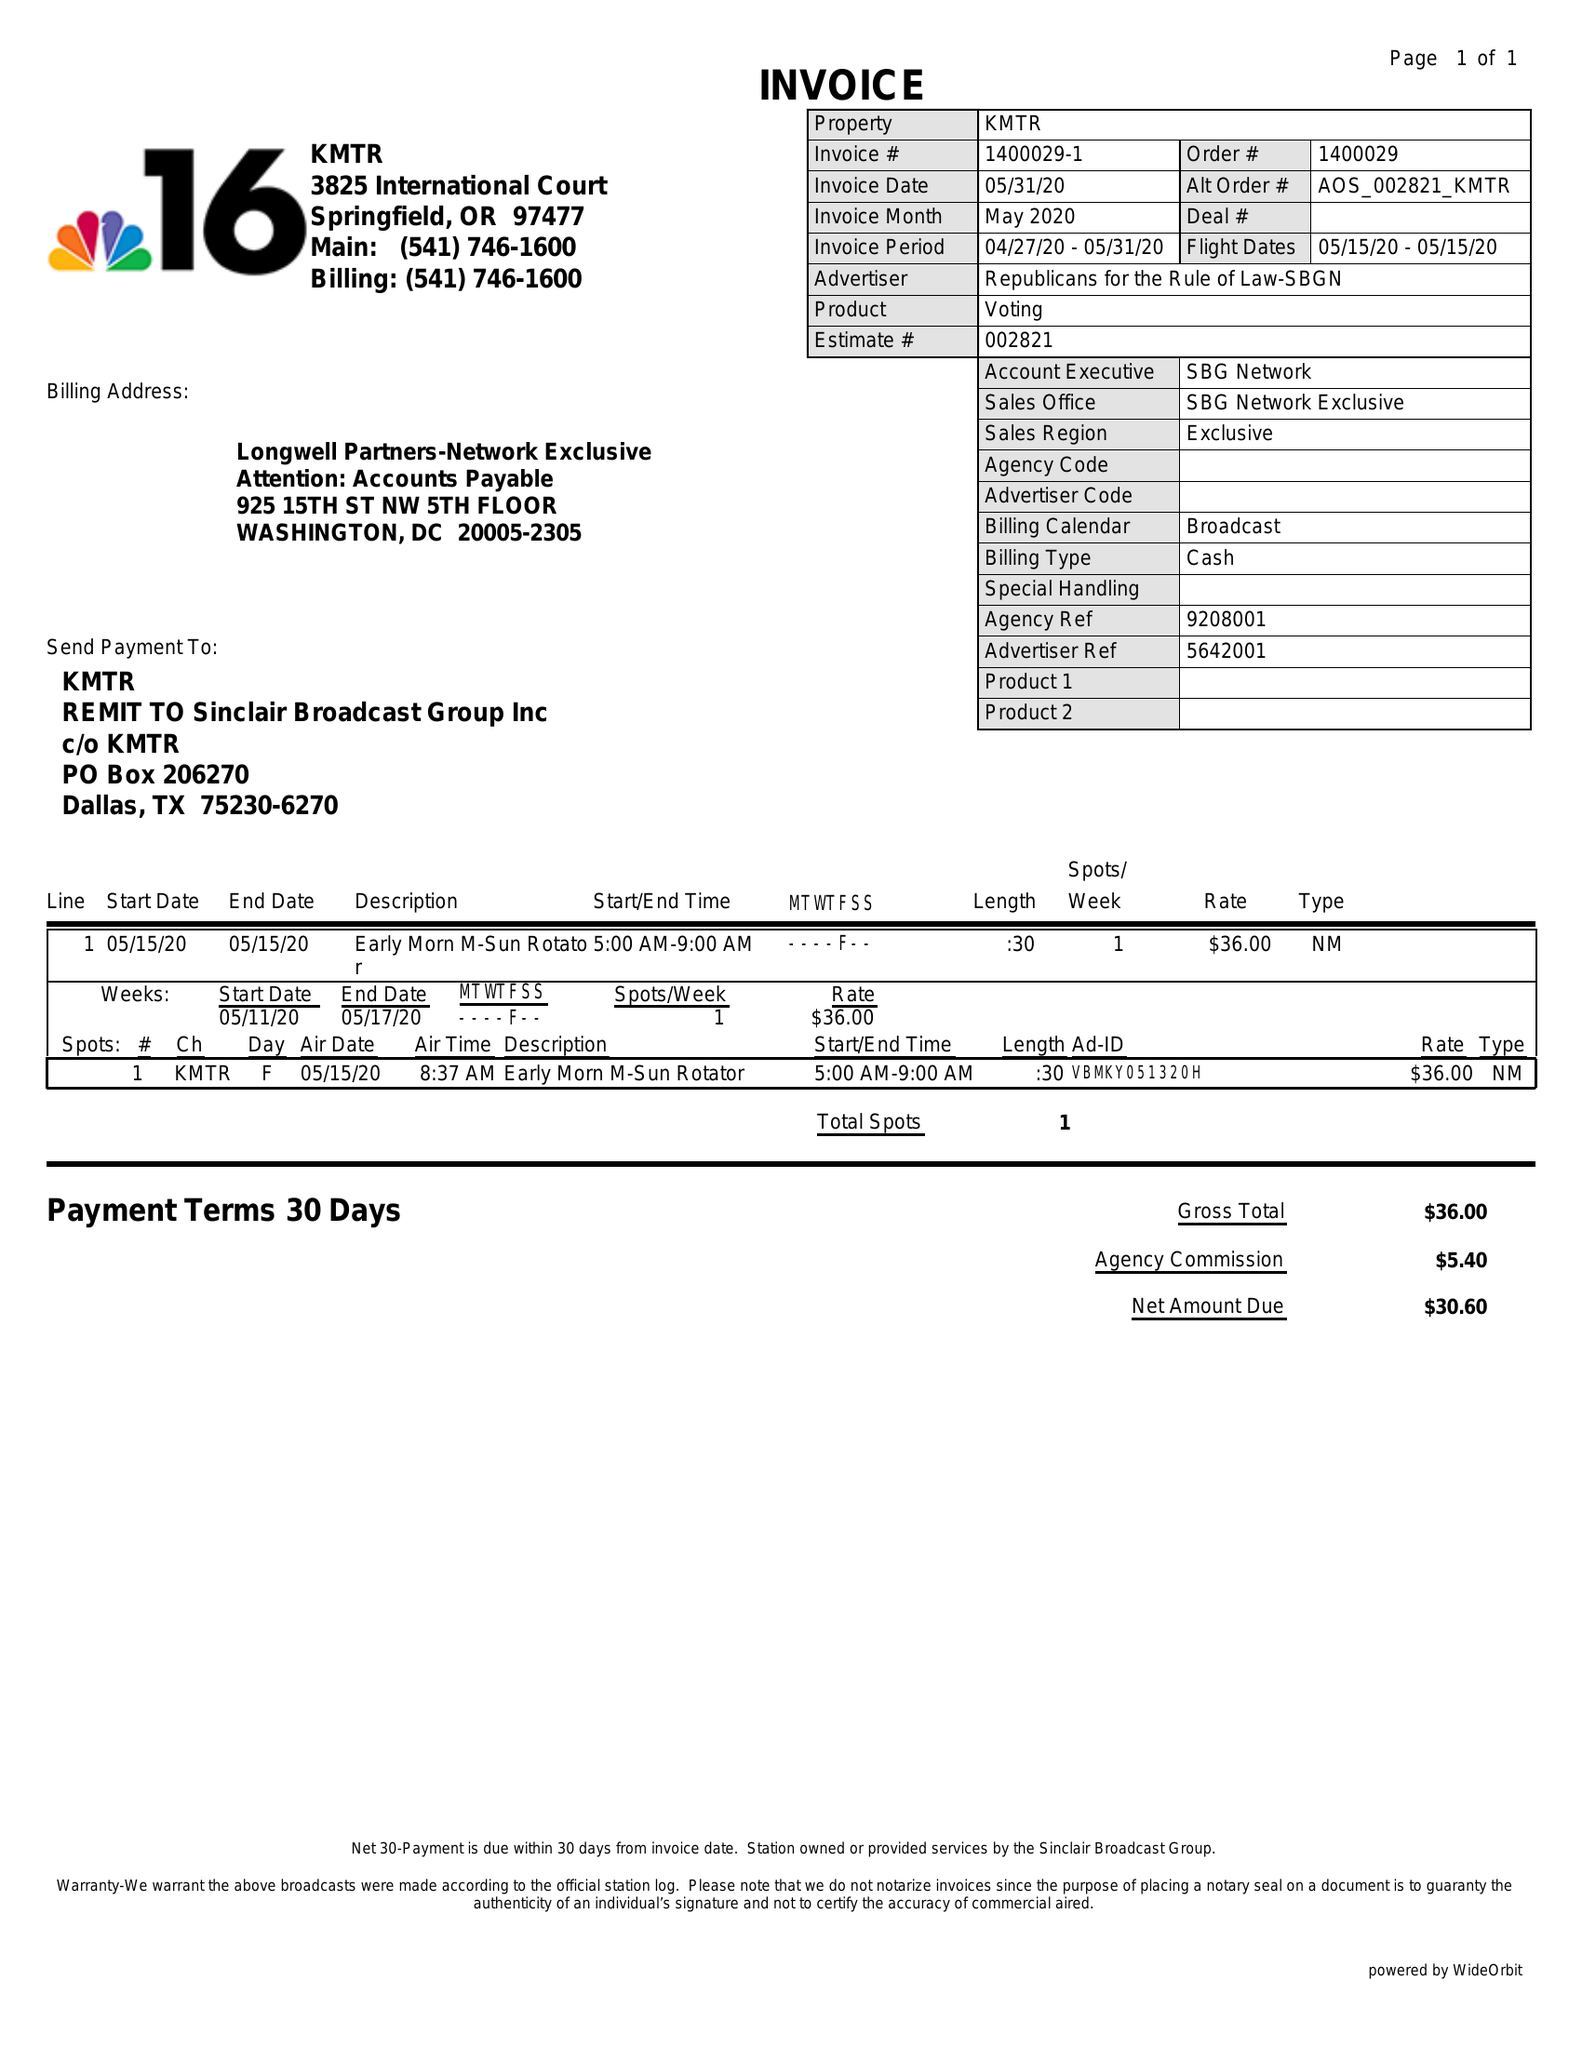What is the value for the contract_num?
Answer the question using a single word or phrase. 1400029 